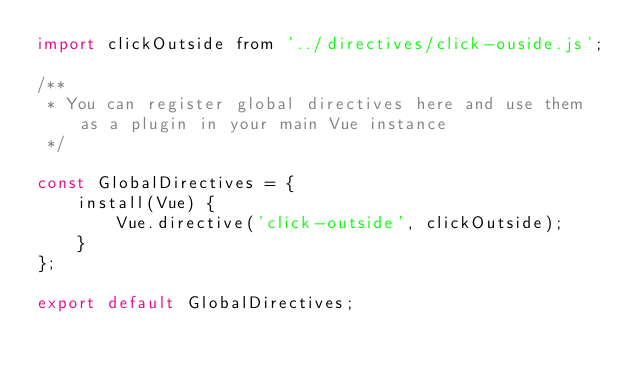<code> <loc_0><loc_0><loc_500><loc_500><_JavaScript_>import clickOutside from '../directives/click-ouside.js';

/**
 * You can register global directives here and use them as a plugin in your main Vue instance
 */

const GlobalDirectives = {
    install(Vue) {
        Vue.directive('click-outside', clickOutside);
    }
};

export default GlobalDirectives;
</code> 